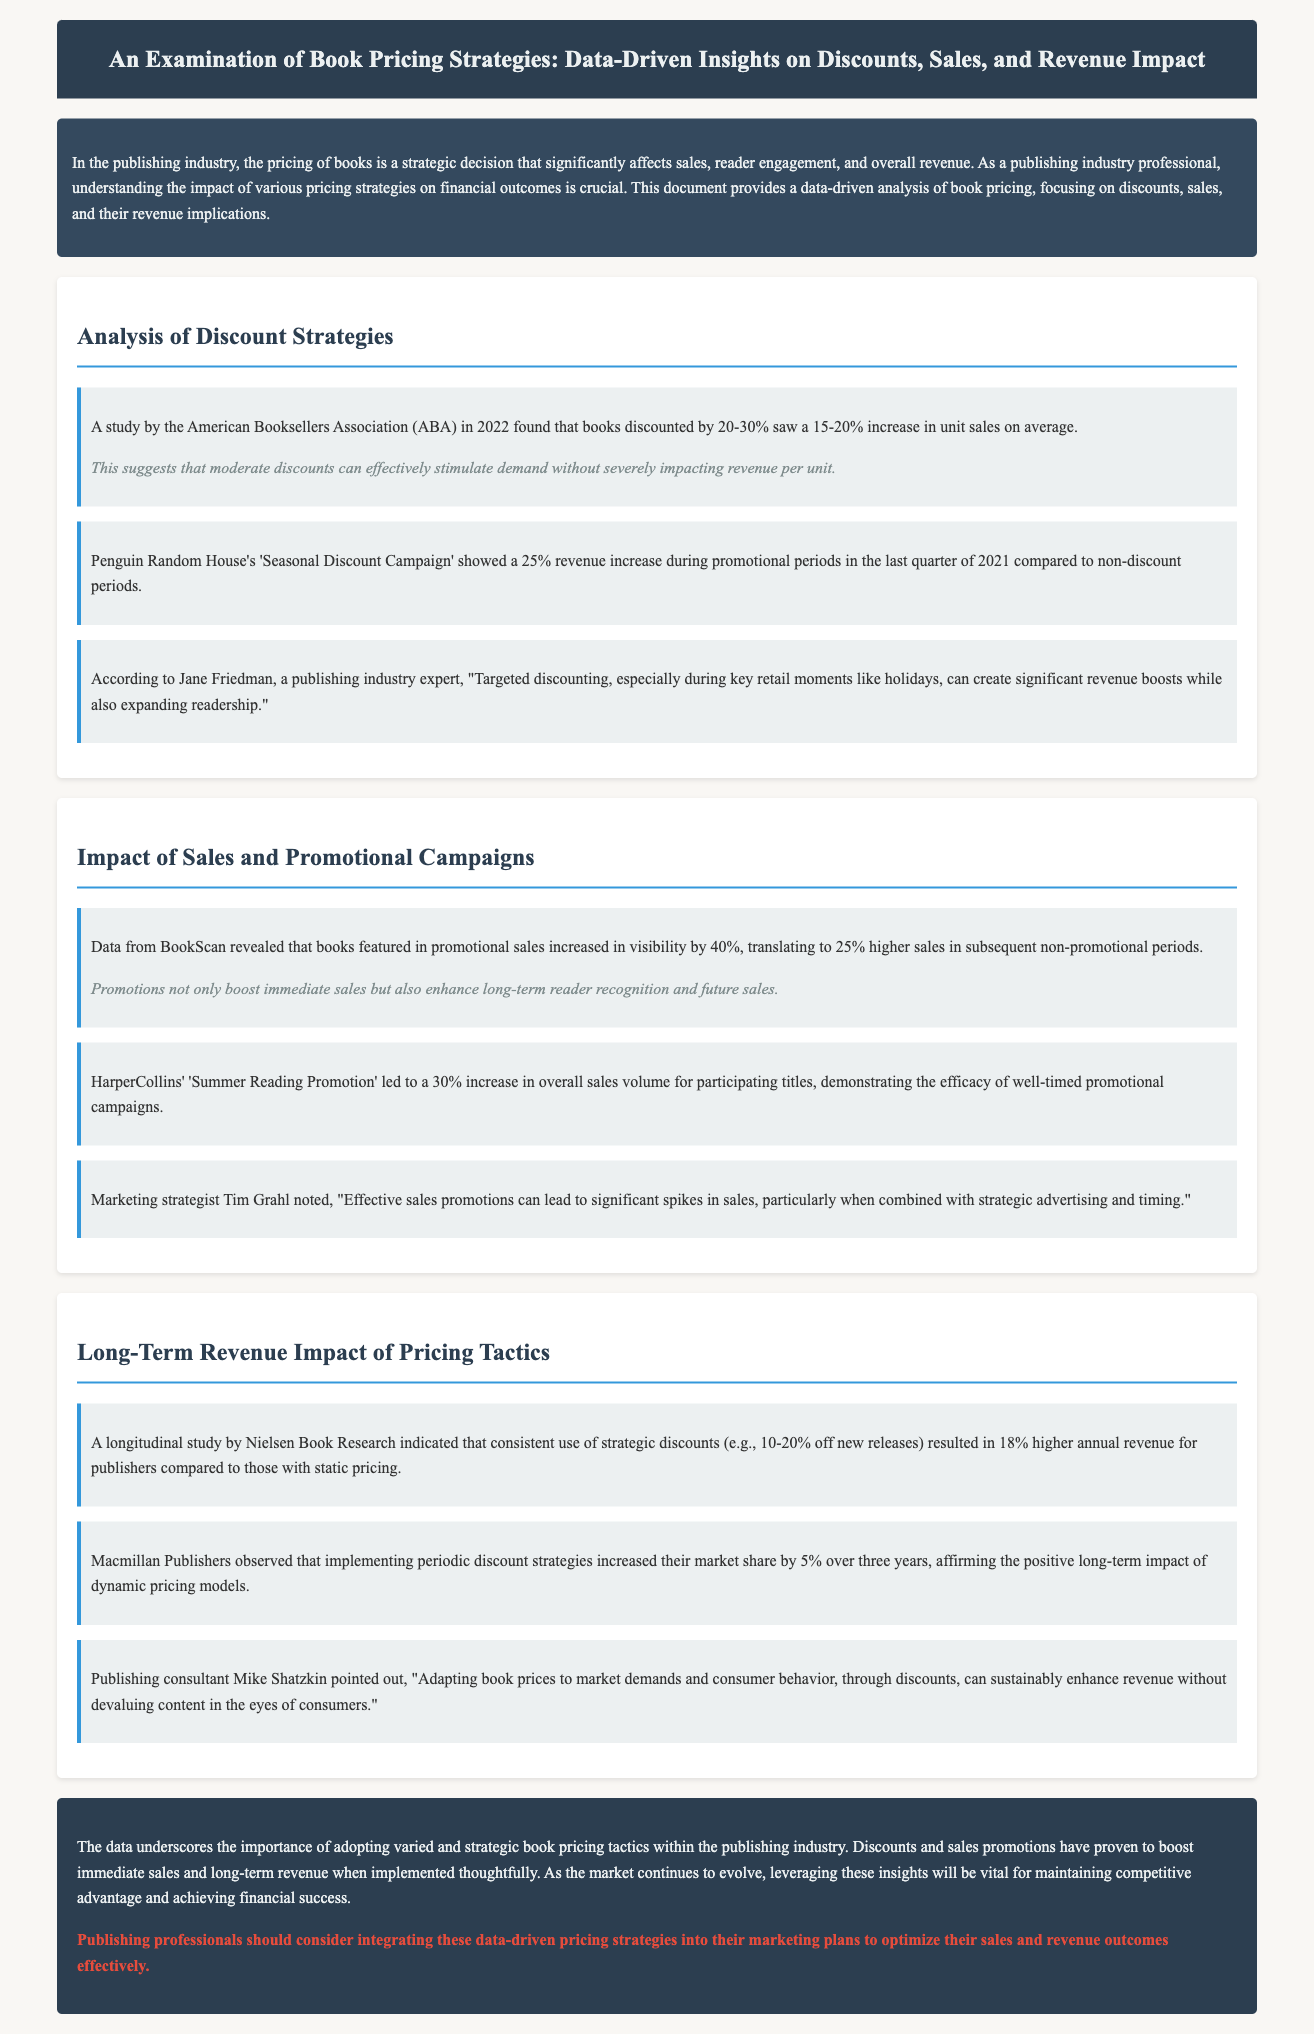What was the percentage increase in unit sales for books discounted by 20-30%? The study by the American Booksellers Association found that books discounted by 20-30% saw a 15-20% increase in unit sales on average.
Answer: 15-20% What was the revenue increase percentage during Penguin Random House's 'Seasonal Discount Campaign'? The campaign showed a 25% revenue increase during promotional periods in the last quarter of 2021 compared to non-discount periods.
Answer: 25% What is the visibility increase percentage for books featured in promotional sales according to BookScan? Data from BookScan revealed that books featured in promotional sales increased in visibility by 40%.
Answer: 40% What is the annual revenue increase percentage for publishers using strategic discounts according to Nielsen Book Research? A longitudinal study indicated that consistent use of strategic discounts resulted in 18% higher annual revenue for publishers.
Answer: 18% Which publisher observed a 5% increase in market share over three years due to periodic discount strategies? Macmillan Publishers implemented periodic discount strategies that increased their market share by 5% over three years.
Answer: Macmillan Publishers What expert noted the importance of timing in effective sales promotions? Marketing strategist Tim Grahl noted the significance of timing in effective sales promotions.
Answer: Tim Grahl What should publishing professionals consider integrating into their marketing plans based on the document's call to action? The call to action emphasizes integrating data-driven pricing strategies into marketing plans to optimize sales outcomes.
Answer: Data-driven pricing strategies 